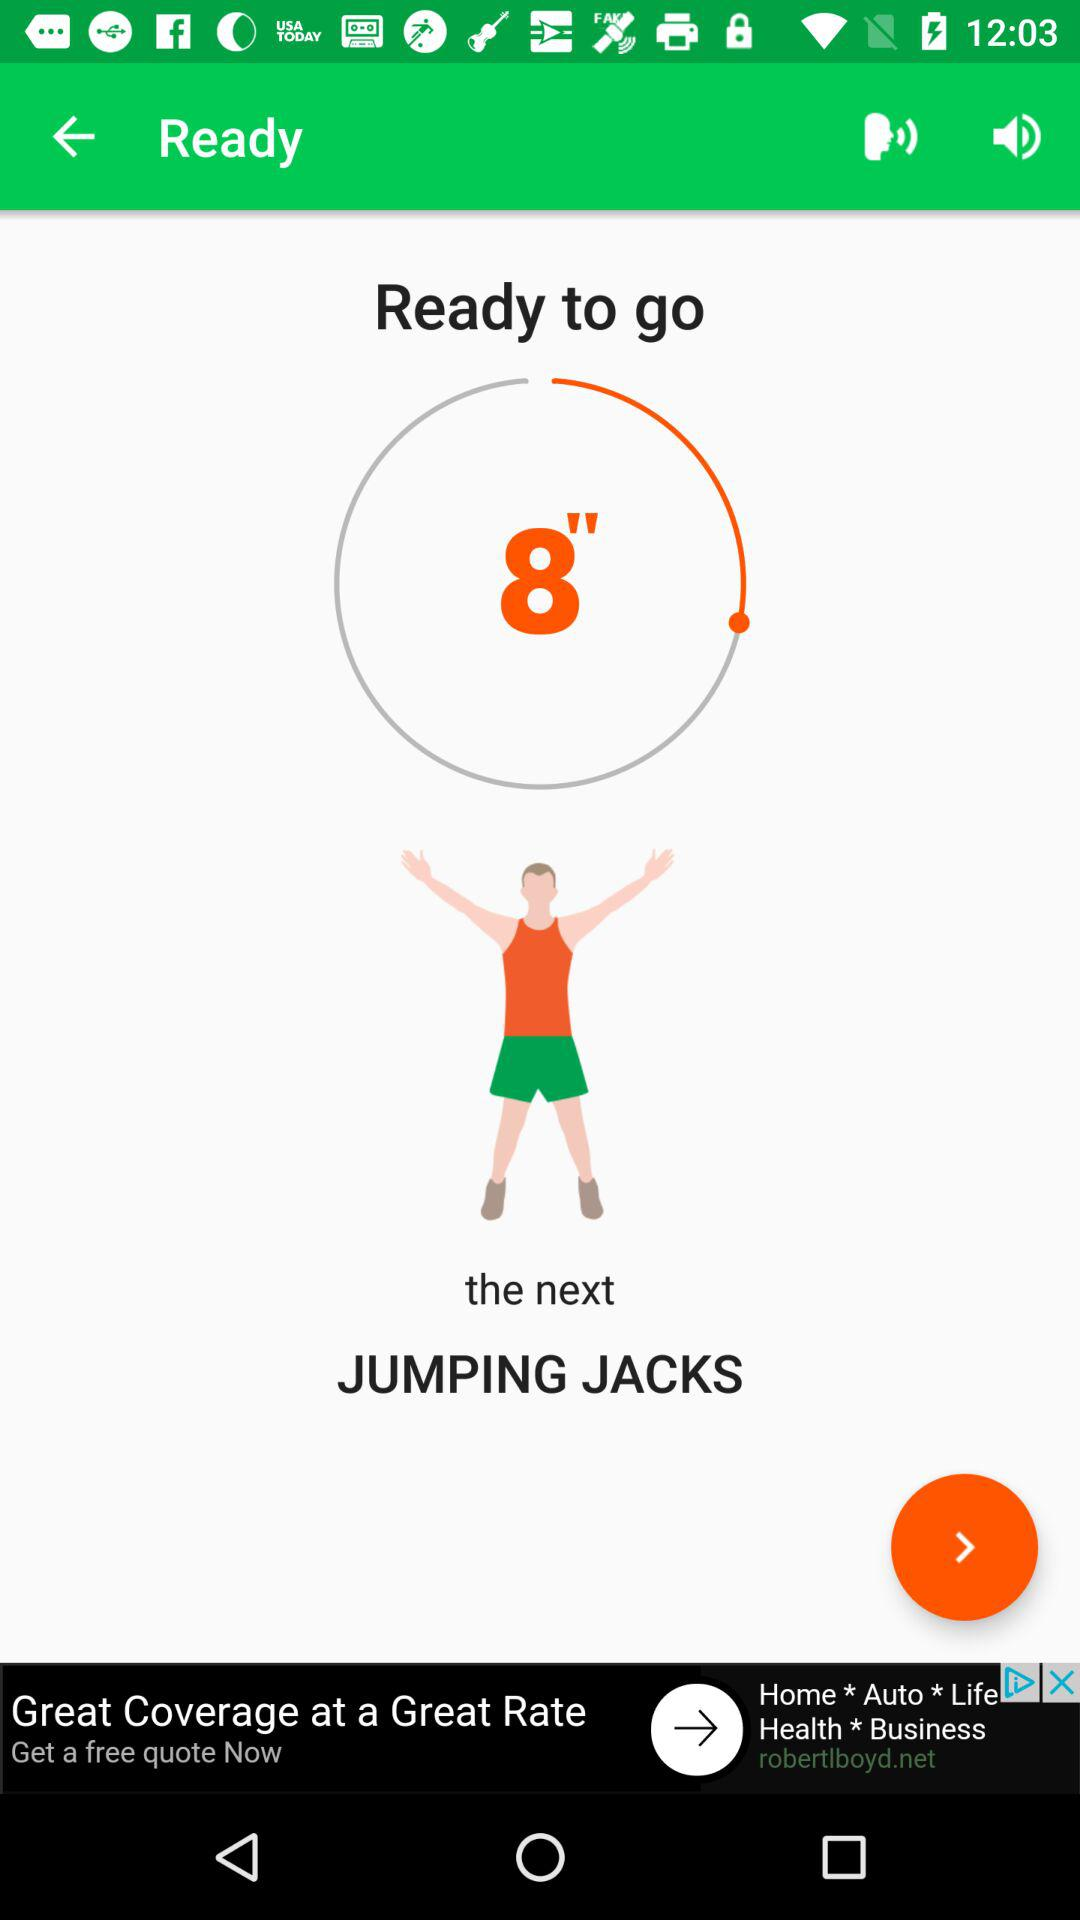Is this a screenshot from a mobile application? Yes, this appears to be a screenshot from a mobile fitness application, specifically one that guides users through various exercises with a timer. Can you tell me what features this app might have, based on the screenshot? Based on the screenshot, this app likely features a workout timer, visual and text-based prompts for transitioning between exercises, and possibly audio cues given the visible volume icon. It may also support workout customization and tracking progress over time. 